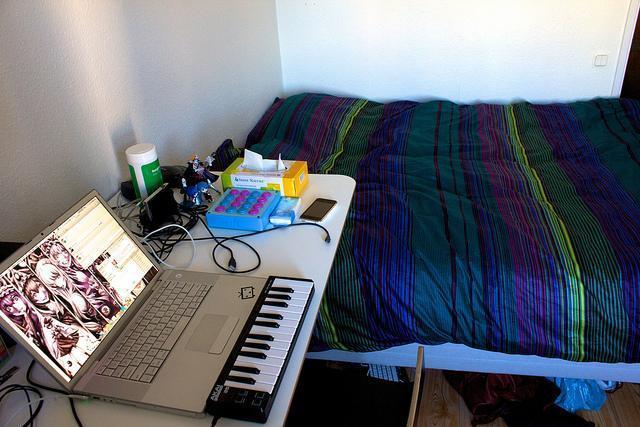How many anime girls are clearly visible on the computer's desktop?
Give a very brief answer. 4. How many chairs are there?
Give a very brief answer. 1. 